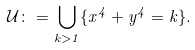Convert formula to latex. <formula><loc_0><loc_0><loc_500><loc_500>\mathcal { U } \colon = \bigcup _ { k > 1 } \{ x ^ { 4 } + y ^ { 4 } = k \} .</formula> 